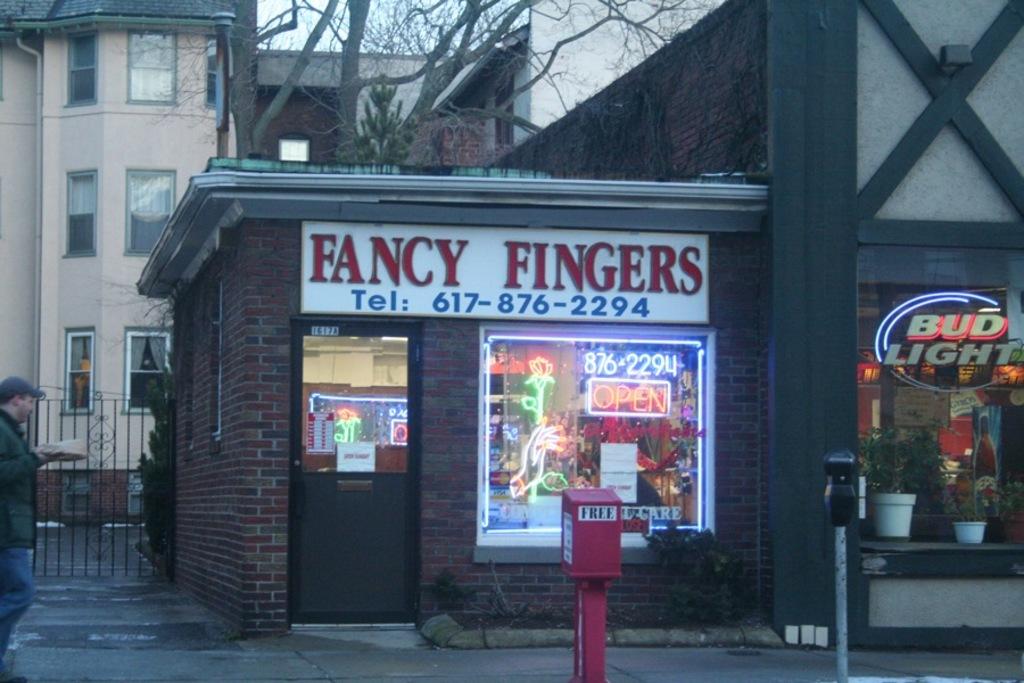What beer does the shop sell?
Your answer should be compact. Bud light. What is the name of the shop in the picture?
Give a very brief answer. Fancy fingers. 